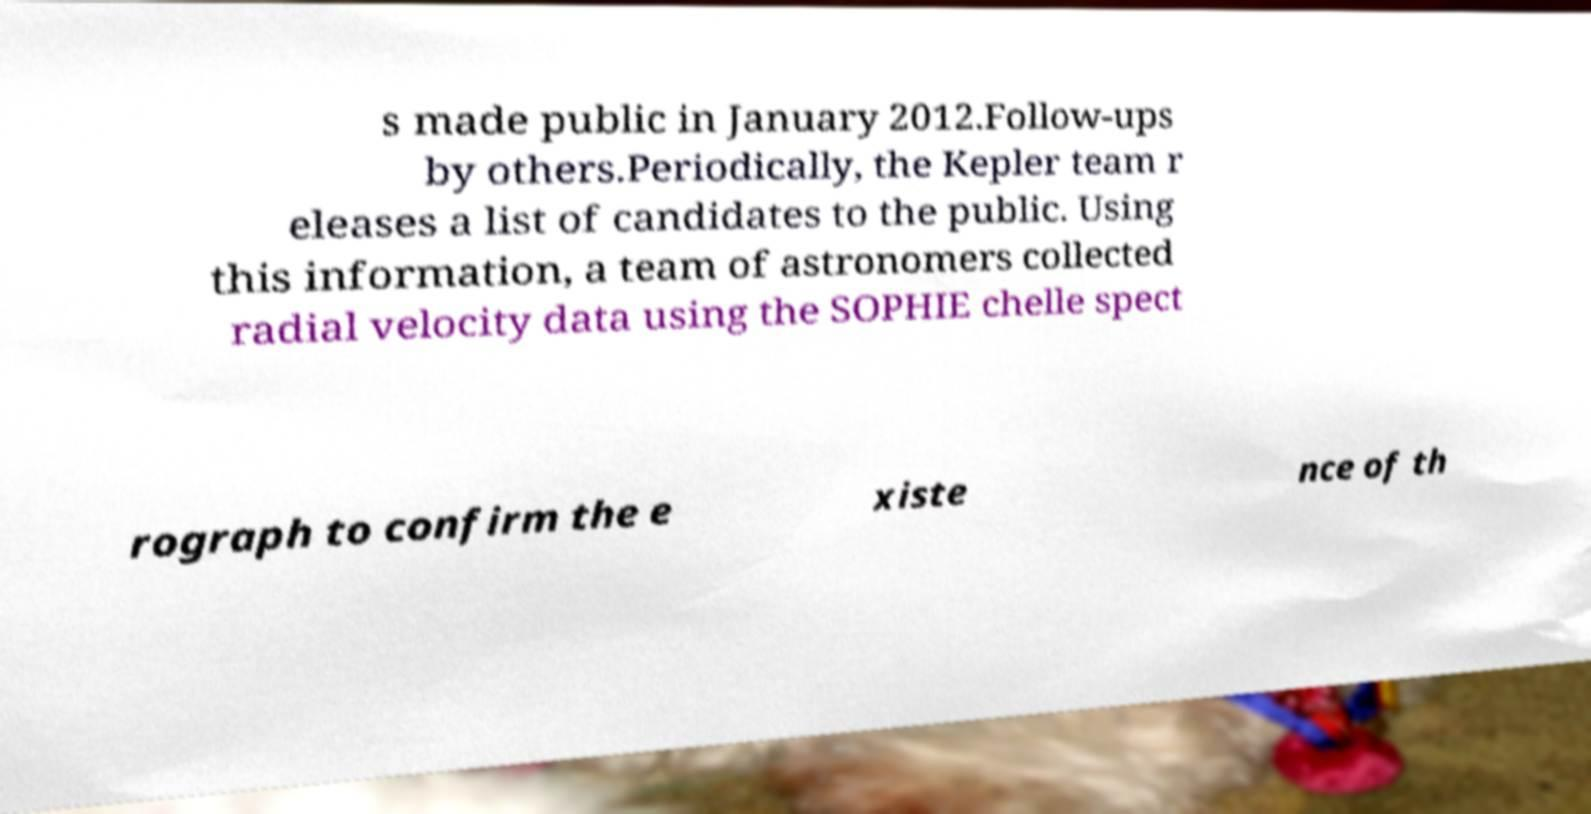Please read and relay the text visible in this image. What does it say? s made public in January 2012.Follow-ups by others.Periodically, the Kepler team r eleases a list of candidates to the public. Using this information, a team of astronomers collected radial velocity data using the SOPHIE chelle spect rograph to confirm the e xiste nce of th 